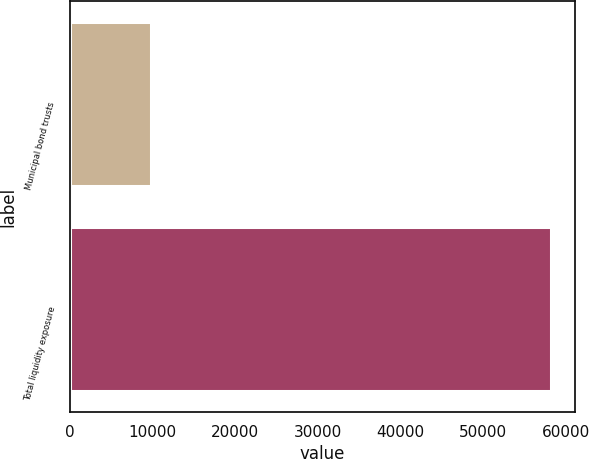Convert chart. <chart><loc_0><loc_0><loc_500><loc_500><bar_chart><fcel>Municipal bond trusts<fcel>Total liquidity exposure<nl><fcel>9784<fcel>58210<nl></chart> 